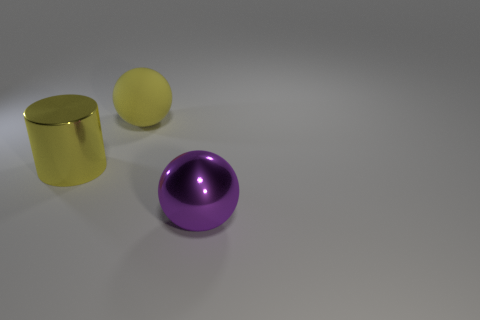How many yellow metal objects are the same size as the yellow metal cylinder?
Ensure brevity in your answer.  0. Does the large purple thing have the same material as the large ball behind the large yellow cylinder?
Offer a very short reply. No. Are there fewer purple spheres than metal things?
Your answer should be compact. Yes. Is there anything else that is the same color as the big metallic sphere?
Keep it short and to the point. No. There is a big thing that is the same material as the big yellow cylinder; what is its shape?
Ensure brevity in your answer.  Sphere. How many big yellow spheres are behind the shiny object that is behind the metal thing right of the yellow matte object?
Offer a terse response. 1. There is a thing that is left of the big purple sphere and in front of the yellow rubber thing; what shape is it?
Give a very brief answer. Cylinder. Is the number of purple objects to the right of the big purple shiny thing less than the number of yellow rubber objects?
Your answer should be compact. Yes. What number of small things are either cyan cylinders or purple things?
Your response must be concise. 0. What is the size of the yellow rubber object?
Keep it short and to the point. Large. 